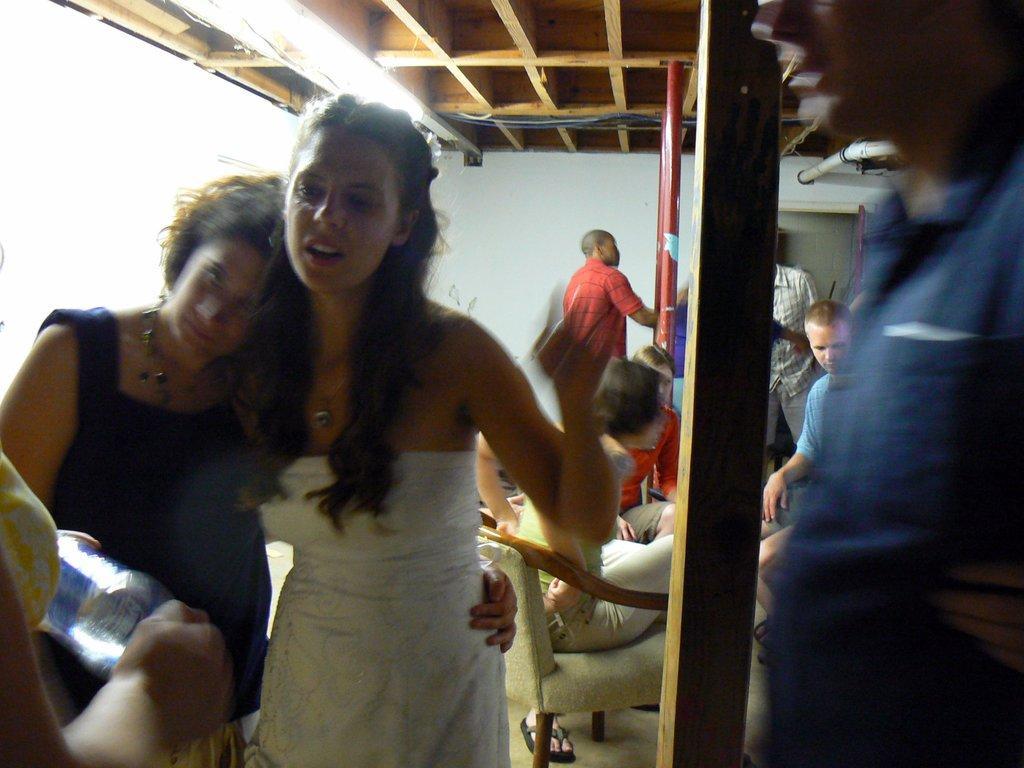Describe this image in one or two sentences. In the image there are few people sitting and standing inside the room and there are lights on the ceiling. 